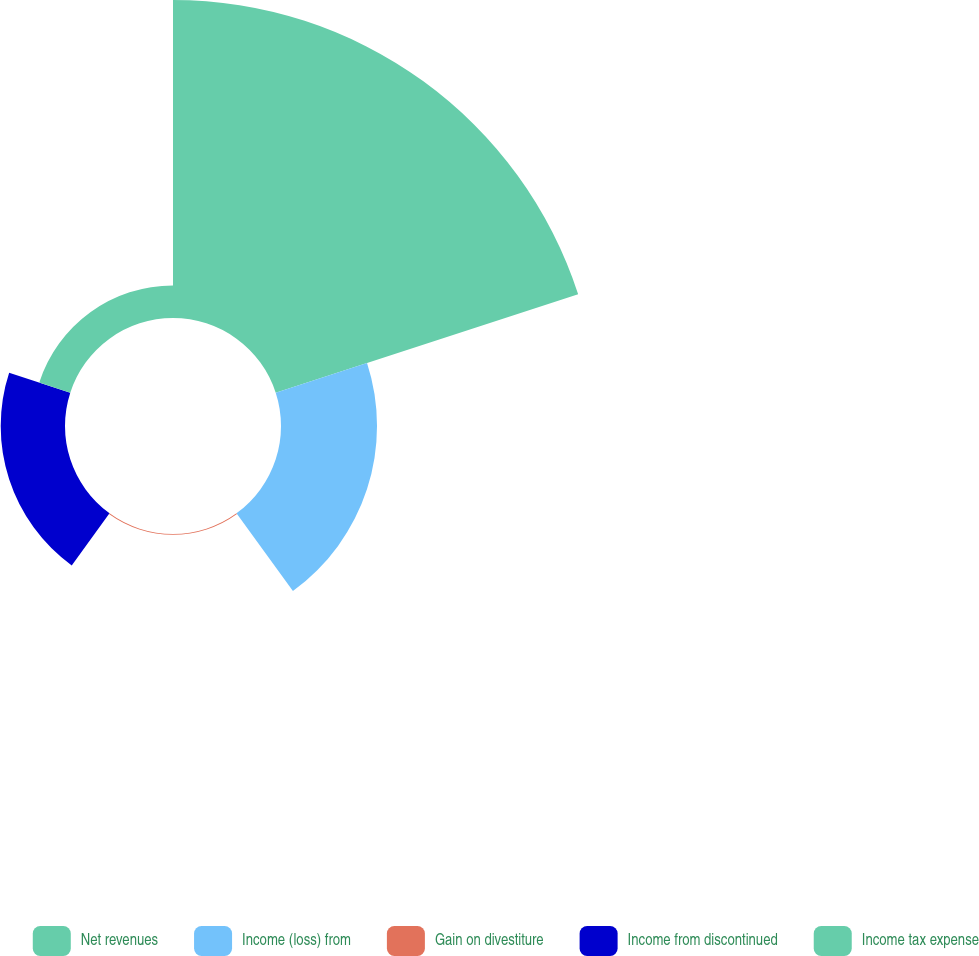Convert chart to OTSL. <chart><loc_0><loc_0><loc_500><loc_500><pie_chart><fcel>Net revenues<fcel>Income (loss) from<fcel>Gain on divestiture<fcel>Income from discontinued<fcel>Income tax expense<nl><fcel>62.13%<fcel>18.76%<fcel>0.17%<fcel>12.56%<fcel>6.37%<nl></chart> 